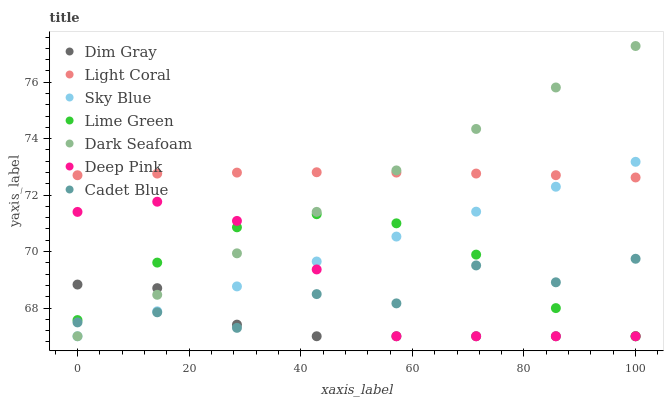Does Dim Gray have the minimum area under the curve?
Answer yes or no. Yes. Does Light Coral have the maximum area under the curve?
Answer yes or no. Yes. Does Cadet Blue have the minimum area under the curve?
Answer yes or no. No. Does Cadet Blue have the maximum area under the curve?
Answer yes or no. No. Is Dark Seafoam the smoothest?
Answer yes or no. Yes. Is Cadet Blue the roughest?
Answer yes or no. Yes. Is Light Coral the smoothest?
Answer yes or no. No. Is Light Coral the roughest?
Answer yes or no. No. Does Dim Gray have the lowest value?
Answer yes or no. Yes. Does Cadet Blue have the lowest value?
Answer yes or no. No. Does Dark Seafoam have the highest value?
Answer yes or no. Yes. Does Cadet Blue have the highest value?
Answer yes or no. No. Is Cadet Blue less than Light Coral?
Answer yes or no. Yes. Is Light Coral greater than Dim Gray?
Answer yes or no. Yes. Does Lime Green intersect Dim Gray?
Answer yes or no. Yes. Is Lime Green less than Dim Gray?
Answer yes or no. No. Is Lime Green greater than Dim Gray?
Answer yes or no. No. Does Cadet Blue intersect Light Coral?
Answer yes or no. No. 